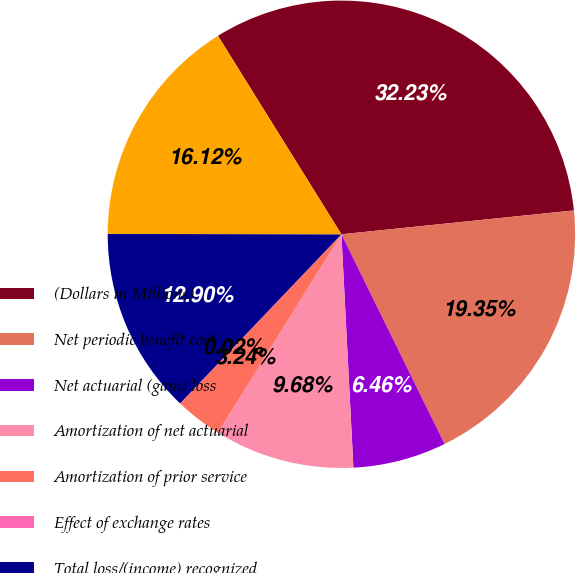Convert chart. <chart><loc_0><loc_0><loc_500><loc_500><pie_chart><fcel>(Dollars in Millions)<fcel>Net periodic benefit cost<fcel>Net actuarial (gain) loss<fcel>Amortization of net actuarial<fcel>Amortization of prior service<fcel>Effect of exchange rates<fcel>Total loss/(income) recognized<fcel>Total recognized in net<nl><fcel>32.23%<fcel>19.35%<fcel>6.46%<fcel>9.68%<fcel>3.24%<fcel>0.02%<fcel>12.9%<fcel>16.12%<nl></chart> 